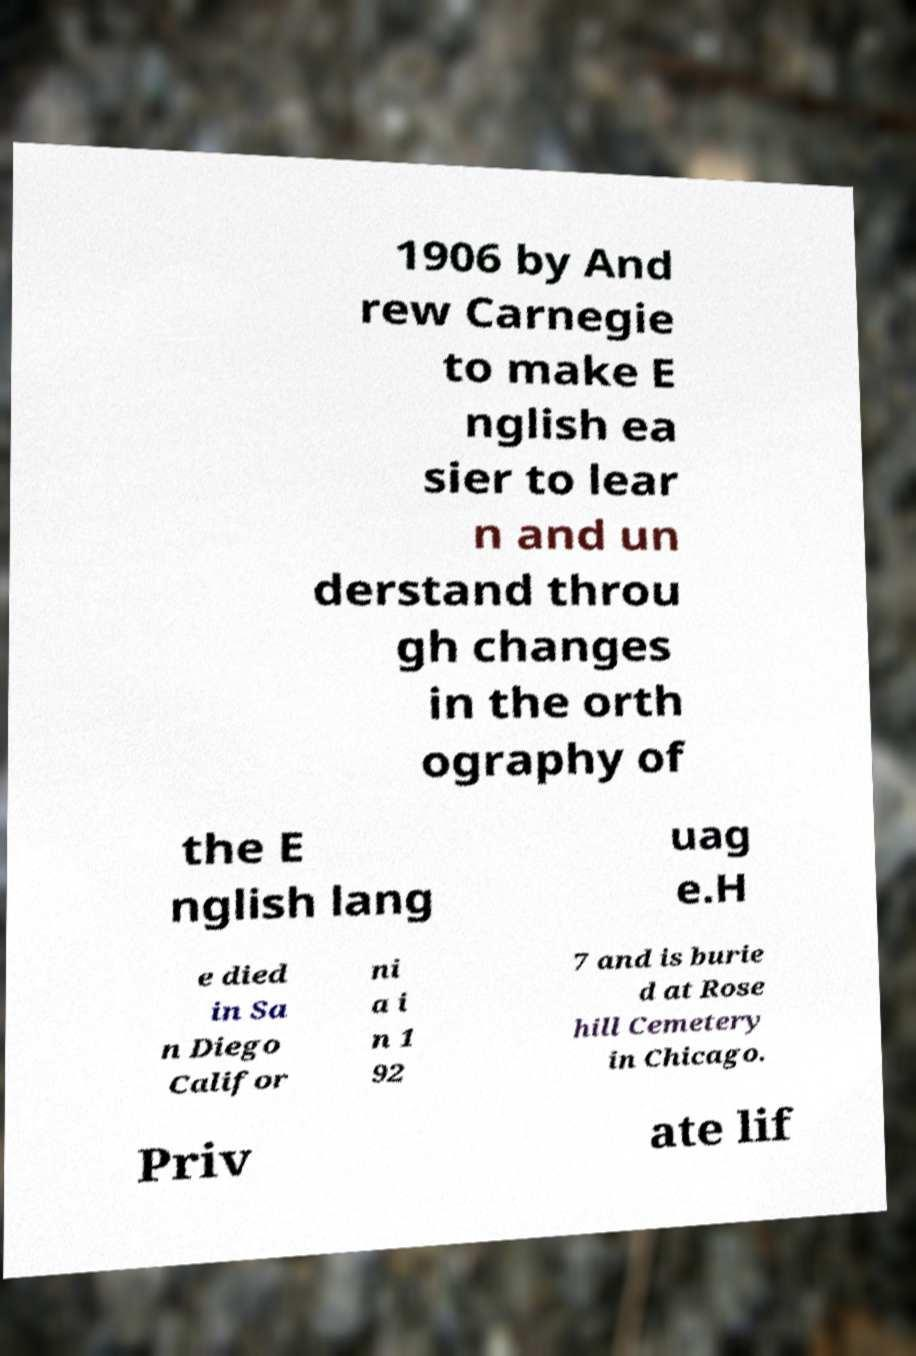What messages or text are displayed in this image? I need them in a readable, typed format. 1906 by And rew Carnegie to make E nglish ea sier to lear n and un derstand throu gh changes in the orth ography of the E nglish lang uag e.H e died in Sa n Diego Califor ni a i n 1 92 7 and is burie d at Rose hill Cemetery in Chicago. Priv ate lif 